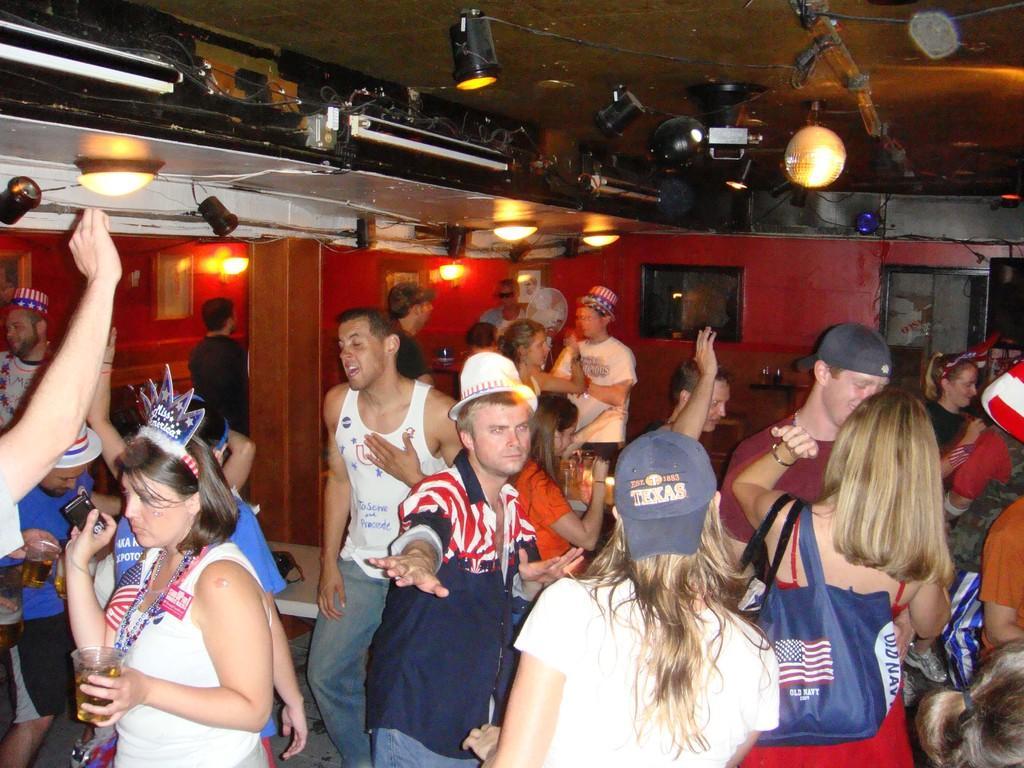Describe this image in one or two sentences. In this image there are some persons dancing as we can see in the bottom of this image and there is a wall in the background. There are some lights arranged on the top of this image. 